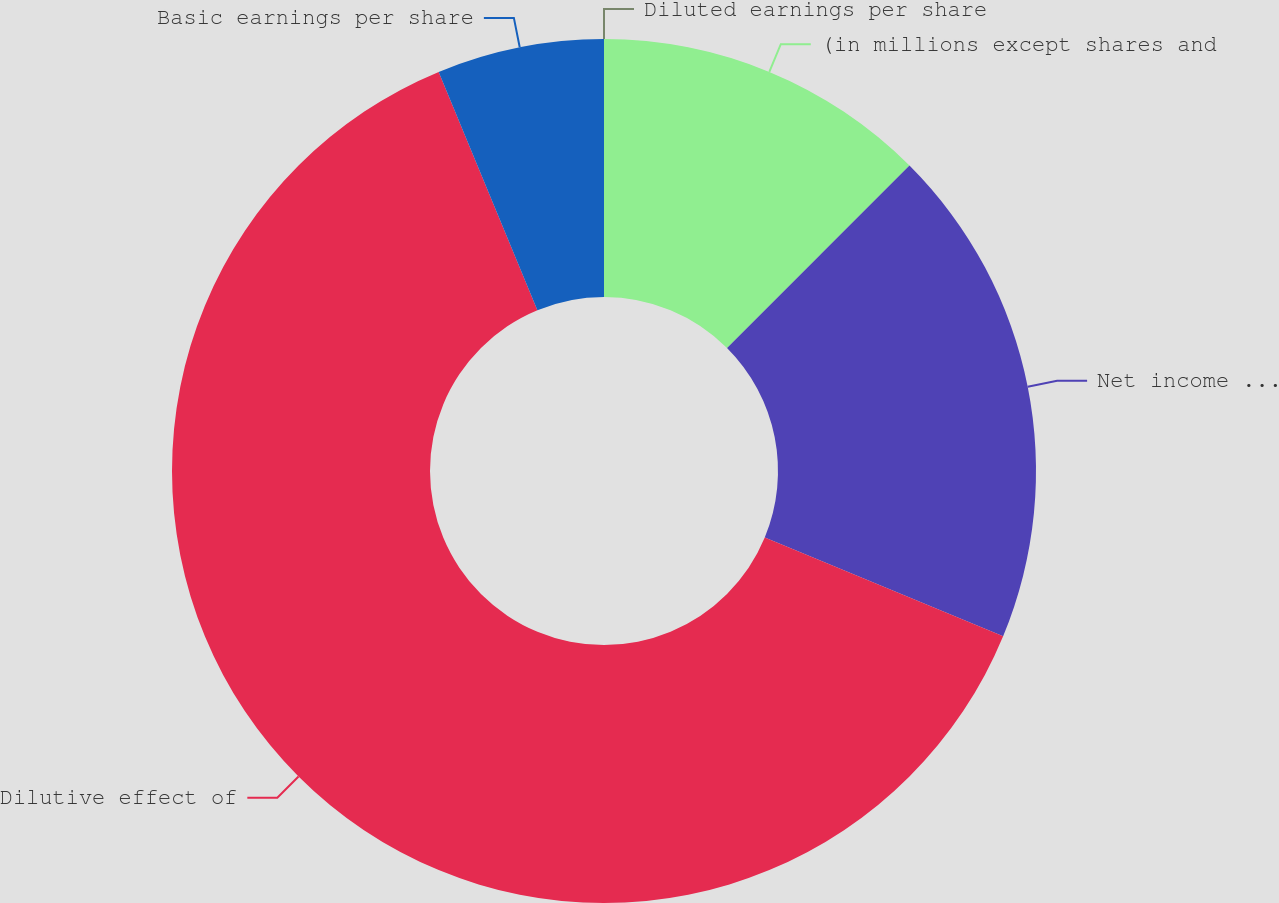Convert chart. <chart><loc_0><loc_0><loc_500><loc_500><pie_chart><fcel>(in millions except shares and<fcel>Net income attributable to<fcel>Dilutive effect of<fcel>Basic earnings per share<fcel>Diluted earnings per share<nl><fcel>12.5%<fcel>18.75%<fcel>62.5%<fcel>6.25%<fcel>0.0%<nl></chart> 